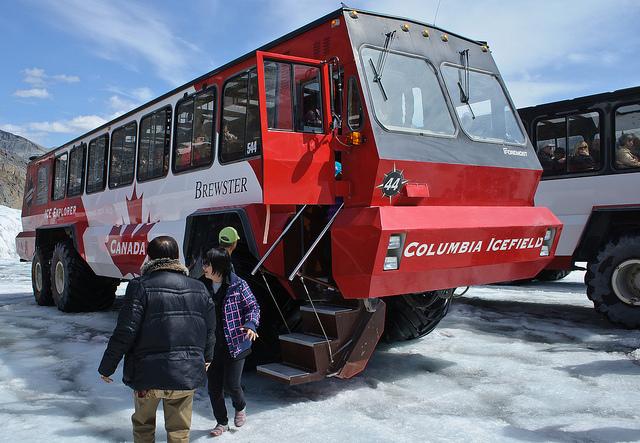Is it cold?
Give a very brief answer. Yes. What is written on the front of the truck?
Short answer required. Columbia icefield. What country's flag is on the side of the vehicle?
Write a very short answer. Canada. 